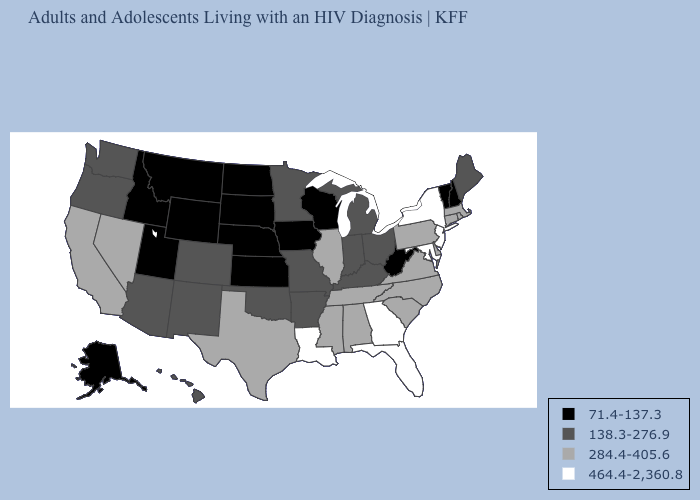What is the value of Wisconsin?
Give a very brief answer. 71.4-137.3. What is the highest value in the MidWest ?
Short answer required. 284.4-405.6. What is the value of South Dakota?
Answer briefly. 71.4-137.3. Name the states that have a value in the range 284.4-405.6?
Give a very brief answer. Alabama, California, Connecticut, Delaware, Illinois, Massachusetts, Mississippi, Nevada, North Carolina, Pennsylvania, Rhode Island, South Carolina, Tennessee, Texas, Virginia. What is the value of Washington?
Short answer required. 138.3-276.9. Does the map have missing data?
Keep it brief. No. What is the value of Georgia?
Be succinct. 464.4-2,360.8. What is the highest value in states that border Iowa?
Be succinct. 284.4-405.6. Name the states that have a value in the range 464.4-2,360.8?
Short answer required. Florida, Georgia, Louisiana, Maryland, New Jersey, New York. Name the states that have a value in the range 464.4-2,360.8?
Short answer required. Florida, Georgia, Louisiana, Maryland, New Jersey, New York. What is the value of Michigan?
Short answer required. 138.3-276.9. Name the states that have a value in the range 71.4-137.3?
Short answer required. Alaska, Idaho, Iowa, Kansas, Montana, Nebraska, New Hampshire, North Dakota, South Dakota, Utah, Vermont, West Virginia, Wisconsin, Wyoming. What is the lowest value in the MidWest?
Give a very brief answer. 71.4-137.3. What is the lowest value in the MidWest?
Be succinct. 71.4-137.3. Which states have the highest value in the USA?
Concise answer only. Florida, Georgia, Louisiana, Maryland, New Jersey, New York. 